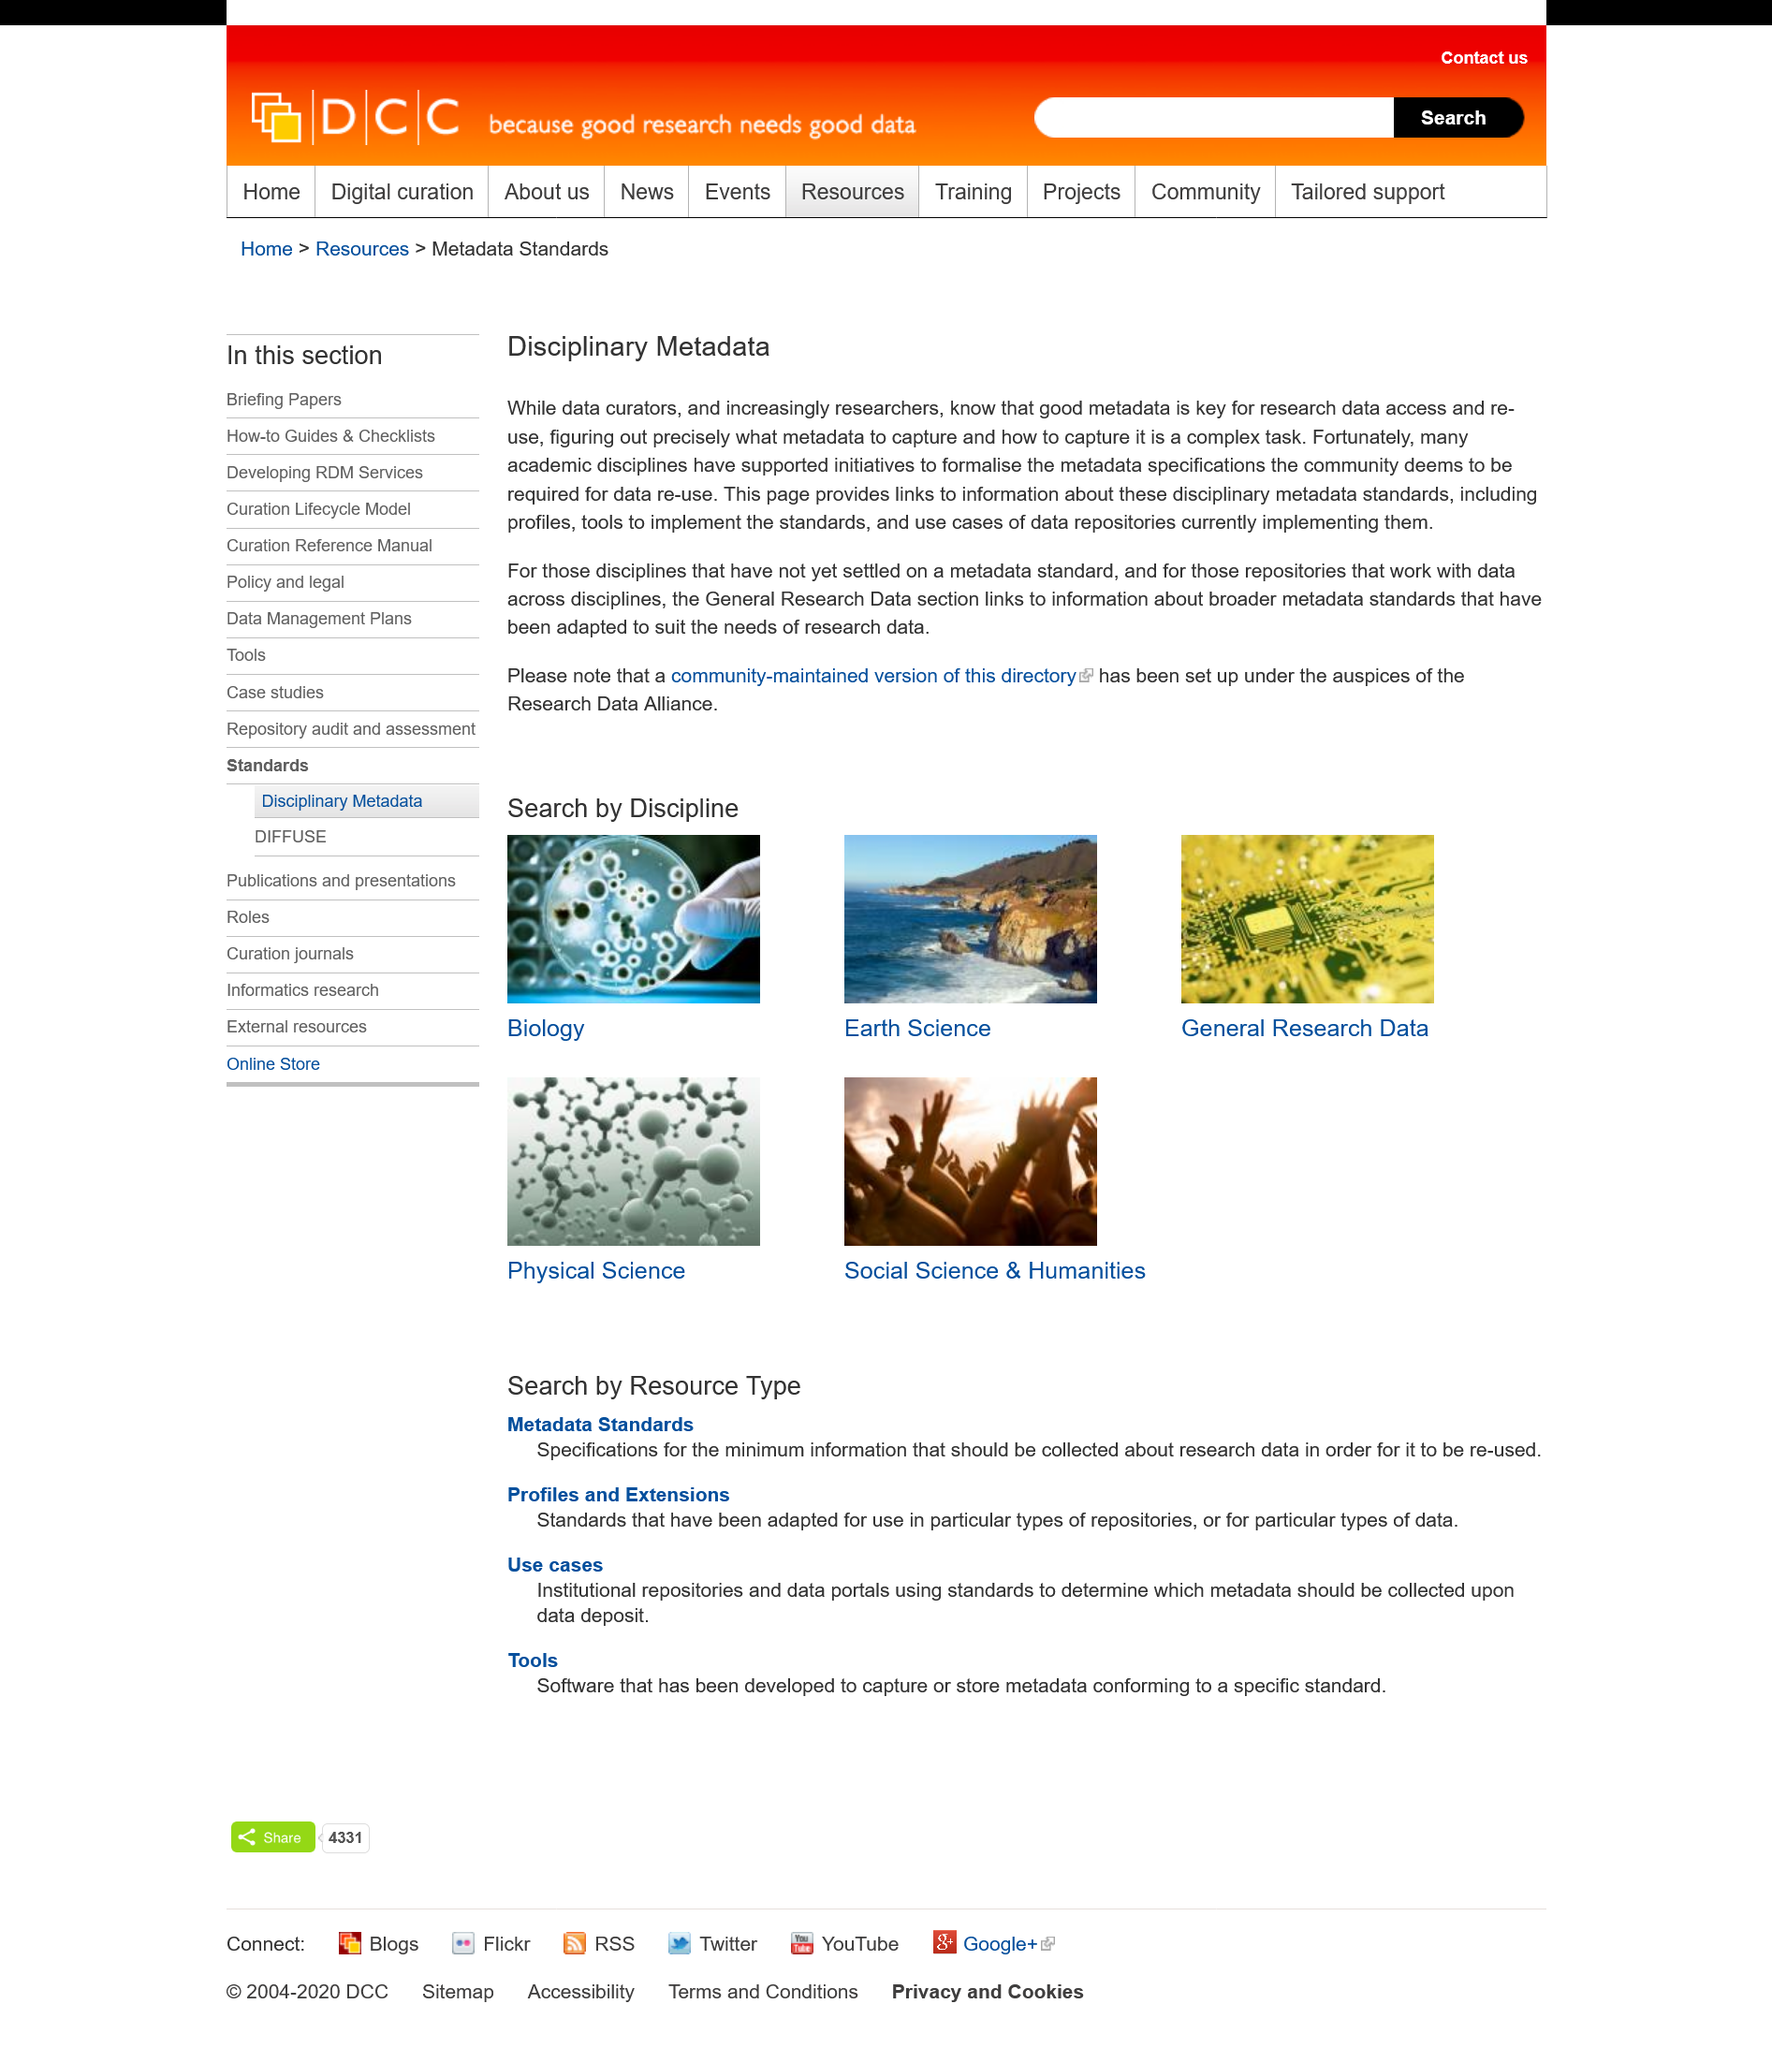Draw attention to some important aspects in this diagram. The title of this page is "Disciplinary Metadata". This page is about the topic of Disciplinary Metadata. Yes, there exists a community maintained version of the directory for the article "Disciplinary Metadata. 